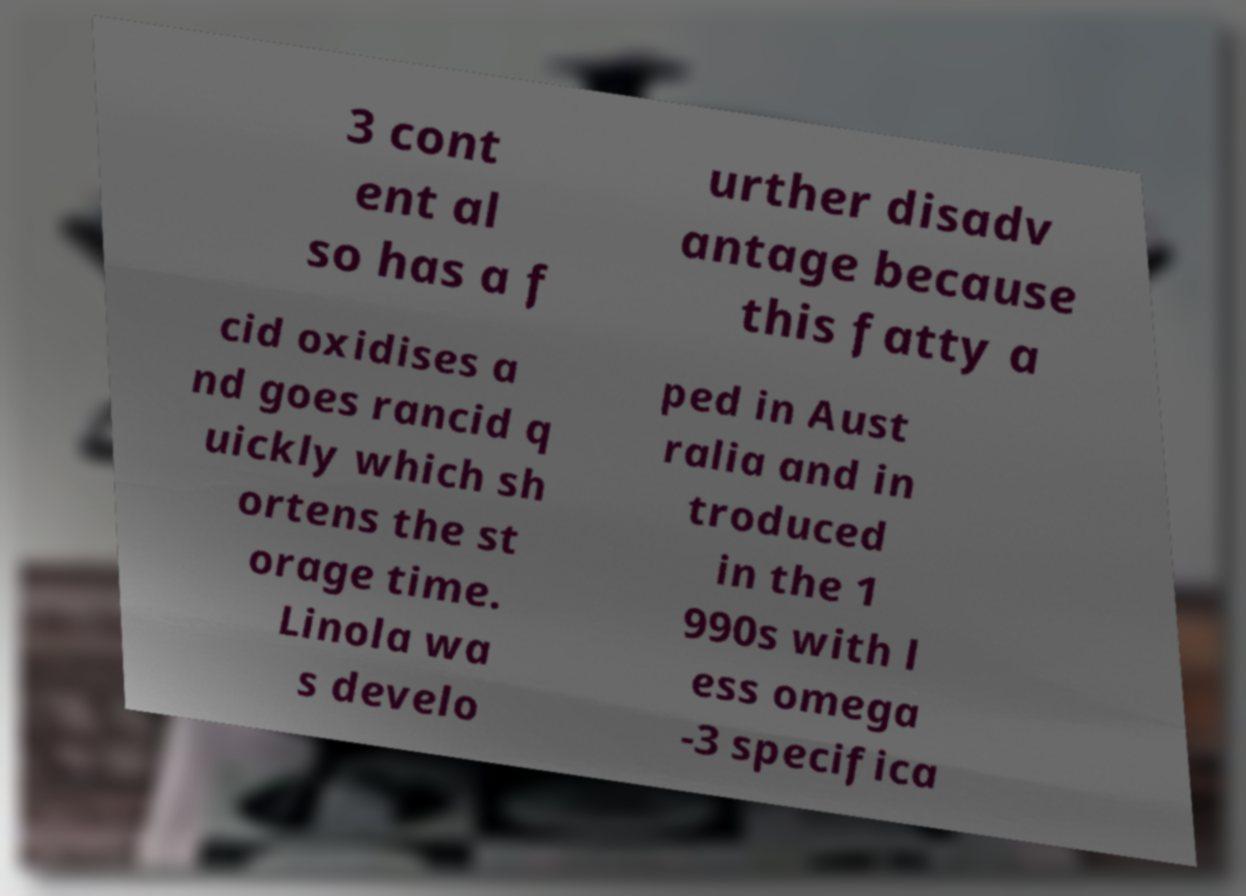Could you extract and type out the text from this image? 3 cont ent al so has a f urther disadv antage because this fatty a cid oxidises a nd goes rancid q uickly which sh ortens the st orage time. Linola wa s develo ped in Aust ralia and in troduced in the 1 990s with l ess omega -3 specifica 